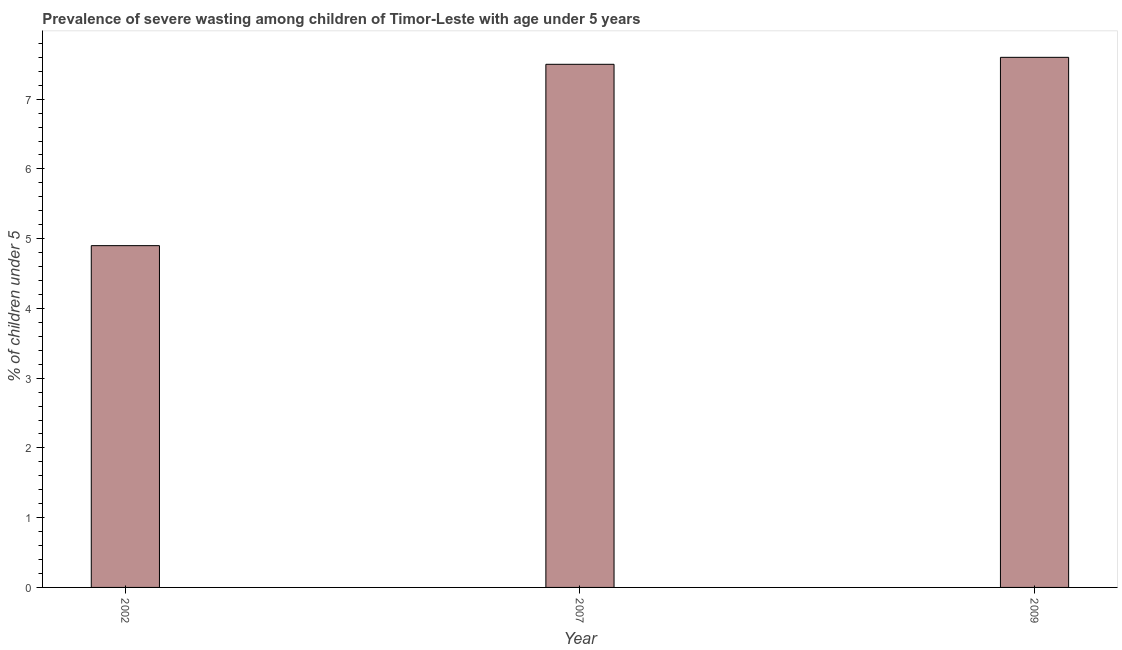Does the graph contain any zero values?
Offer a very short reply. No. What is the title of the graph?
Provide a succinct answer. Prevalence of severe wasting among children of Timor-Leste with age under 5 years. What is the label or title of the Y-axis?
Ensure brevity in your answer.   % of children under 5. Across all years, what is the maximum prevalence of severe wasting?
Give a very brief answer. 7.6. Across all years, what is the minimum prevalence of severe wasting?
Your response must be concise. 4.9. In which year was the prevalence of severe wasting maximum?
Your answer should be compact. 2009. What is the difference between the prevalence of severe wasting in 2002 and 2007?
Give a very brief answer. -2.6. What is the average prevalence of severe wasting per year?
Offer a terse response. 6.67. In how many years, is the prevalence of severe wasting greater than 3 %?
Give a very brief answer. 3. Do a majority of the years between 2002 and 2009 (inclusive) have prevalence of severe wasting greater than 5 %?
Provide a short and direct response. Yes. What is the ratio of the prevalence of severe wasting in 2002 to that in 2007?
Provide a short and direct response. 0.65. What is the difference between the highest and the second highest prevalence of severe wasting?
Your answer should be very brief. 0.1. Is the sum of the prevalence of severe wasting in 2002 and 2009 greater than the maximum prevalence of severe wasting across all years?
Offer a very short reply. Yes. What is the difference between the highest and the lowest prevalence of severe wasting?
Provide a succinct answer. 2.7. In how many years, is the prevalence of severe wasting greater than the average prevalence of severe wasting taken over all years?
Your response must be concise. 2. What is the difference between two consecutive major ticks on the Y-axis?
Offer a terse response. 1. Are the values on the major ticks of Y-axis written in scientific E-notation?
Provide a succinct answer. No. What is the  % of children under 5 of 2002?
Your answer should be very brief. 4.9. What is the  % of children under 5 in 2009?
Your answer should be compact. 7.6. What is the difference between the  % of children under 5 in 2007 and 2009?
Your response must be concise. -0.1. What is the ratio of the  % of children under 5 in 2002 to that in 2007?
Keep it short and to the point. 0.65. What is the ratio of the  % of children under 5 in 2002 to that in 2009?
Make the answer very short. 0.65. 